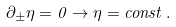<formula> <loc_0><loc_0><loc_500><loc_500>\partial _ { \pm } \eta = 0 \rightarrow \eta = c o n s t \, .</formula> 